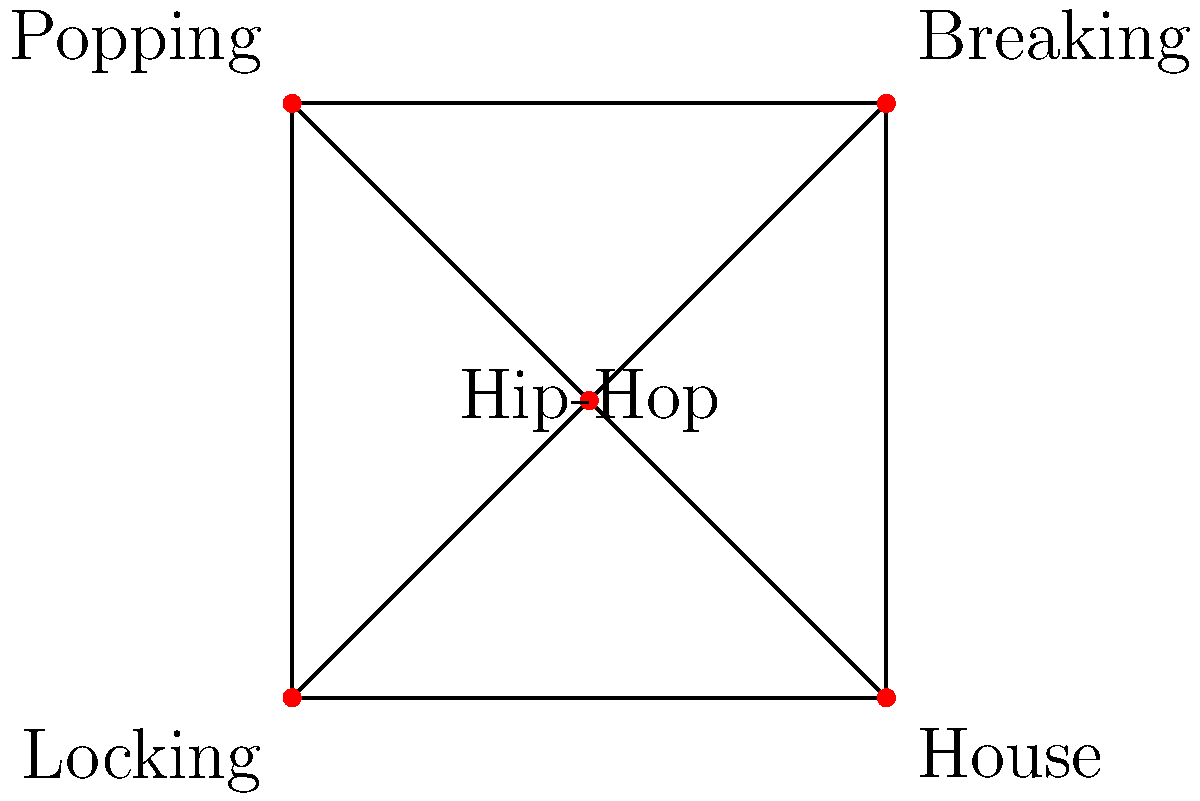In the given cultural fusion network of street dance styles, what is the degree of the "Hip-Hop" node, and how does this relate to its role in street dance fusion? To answer this question, we need to follow these steps:

1. Understand the concept of degree in graph theory:
   - The degree of a node is the number of edges connected to it.

2. Identify the "Hip-Hop" node in the graph:
   - The "Hip-Hop" node is at the center of the graph.

3. Count the number of edges connected to the "Hip-Hop" node:
   - We can see that Hip-Hop is directly connected to Breaking, Popping, Locking, and House.
   - There are 4 edges connected to the Hip-Hop node.

4. Determine the degree of the "Hip-Hop" node:
   - The degree of the Hip-Hop node is 4.

5. Interpret the meaning of this degree in the context of street dance fusion:
   - A high degree (4 out of a possible 4 in this graph) indicates that Hip-Hop is highly connected to other dance styles.
   - This suggests that Hip-Hop plays a central role in street dance fusion, acting as a hub that connects various styles.
   - The high connectivity implies that Hip-Hop often incorporates elements from or influences other street dance styles, making it versatile for cultural fusion.

Therefore, the degree of the "Hip-Hop" node is 4, which reflects its central and influential role in street dance fusion, connecting and integrating various dance styles.
Answer: Degree: 4; Central hub for fusion 